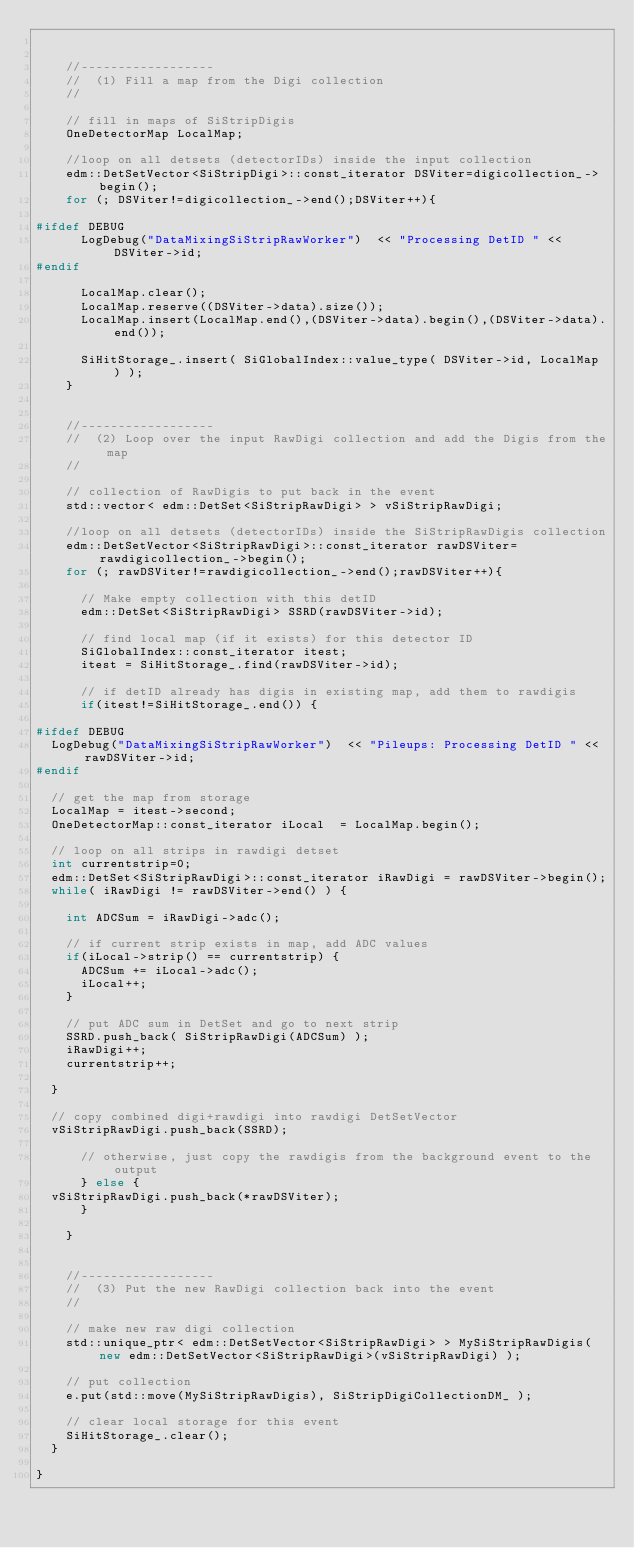Convert code to text. <code><loc_0><loc_0><loc_500><loc_500><_C++_>

    //------------------
    //  (1) Fill a map from the Digi collection
    //

    // fill in maps of SiStripDigis
    OneDetectorMap LocalMap;
    
    //loop on all detsets (detectorIDs) inside the input collection
    edm::DetSetVector<SiStripDigi>::const_iterator DSViter=digicollection_->begin();
    for (; DSViter!=digicollection_->end();DSViter++){
      
#ifdef DEBUG
      LogDebug("DataMixingSiStripRawWorker")  << "Processing DetID " << DSViter->id;
#endif
      
      LocalMap.clear();
      LocalMap.reserve((DSViter->data).size());
      LocalMap.insert(LocalMap.end(),(DSViter->data).begin(),(DSViter->data).end());	
      
      SiHitStorage_.insert( SiGlobalIndex::value_type( DSViter->id, LocalMap ) );
    }


    //------------------
    //  (2) Loop over the input RawDigi collection and add the Digis from the map
    //

    // collection of RawDigis to put back in the event
    std::vector< edm::DetSet<SiStripRawDigi> > vSiStripRawDigi;

    //loop on all detsets (detectorIDs) inside the SiStripRawDigis collection
    edm::DetSetVector<SiStripRawDigi>::const_iterator rawDSViter=rawdigicollection_->begin();
    for (; rawDSViter!=rawdigicollection_->end();rawDSViter++){

      // Make empty collection with this detID
      edm::DetSet<SiStripRawDigi> SSRD(rawDSViter->id); 

      // find local map (if it exists) for this detector ID
      SiGlobalIndex::const_iterator itest;
      itest = SiHitStorage_.find(rawDSViter->id);

      // if detID already has digis in existing map, add them to rawdigis
      if(itest!=SiHitStorage_.end()) {  

#ifdef DEBUG
	LogDebug("DataMixingSiStripRawWorker")  << "Pileups: Processing DetID " << rawDSViter->id;
#endif

	// get the map from storage
	LocalMap = itest->second;
	OneDetectorMap::const_iterator iLocal  = LocalMap.begin();

	// loop on all strips in rawdigi detset
	int currentstrip=0;
	edm::DetSet<SiStripRawDigi>::const_iterator iRawDigi = rawDSViter->begin();
	while( iRawDigi != rawDSViter->end() ) {

	  int ADCSum = iRawDigi->adc();

	  // if current strip exists in map, add ADC values
	  if(iLocal->strip() == currentstrip) {
	    ADCSum += iLocal->adc();
	    iLocal++;
	  }

	  // put ADC sum in DetSet and go to next strip
	  SSRD.push_back( SiStripRawDigi(ADCSum) );
	  iRawDigi++;
	  currentstrip++;

	}

	// copy combined digi+rawdigi into rawdigi DetSetVector
	vSiStripRawDigi.push_back(SSRD);

      // otherwise, just copy the rawdigis from the background event to the output
      } else {
	vSiStripRawDigi.push_back(*rawDSViter);
      }

    }


    //------------------
    //  (3) Put the new RawDigi collection back into the event
    //

    // make new raw digi collection
    std::unique_ptr< edm::DetSetVector<SiStripRawDigi> > MySiStripRawDigis(new edm::DetSetVector<SiStripRawDigi>(vSiStripRawDigi) );

    // put collection
    e.put(std::move(MySiStripRawDigis), SiStripDigiCollectionDM_ );

    // clear local storage for this event
    SiHitStorage_.clear();
  }

}
</code> 